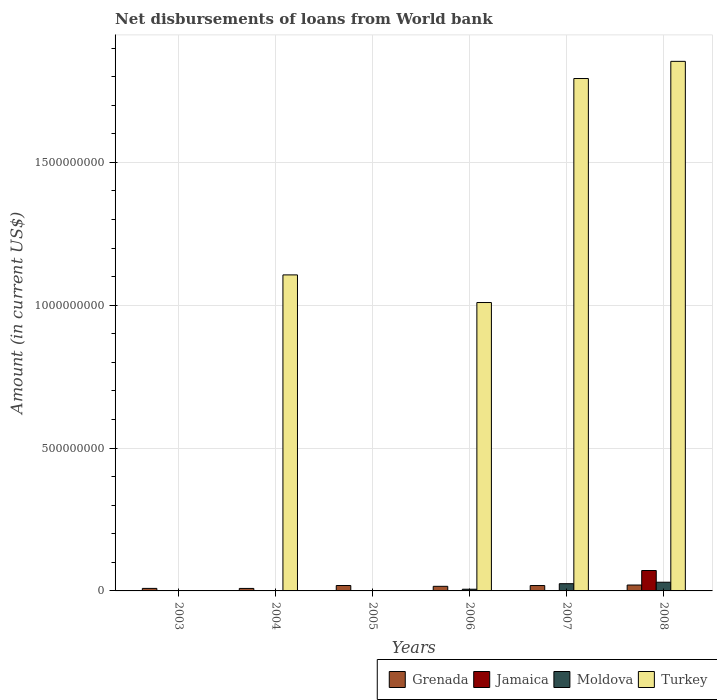How many different coloured bars are there?
Offer a very short reply. 4. Are the number of bars per tick equal to the number of legend labels?
Ensure brevity in your answer.  No. Are the number of bars on each tick of the X-axis equal?
Offer a terse response. No. How many bars are there on the 5th tick from the right?
Provide a succinct answer. 3. What is the label of the 3rd group of bars from the left?
Your response must be concise. 2005. In how many cases, is the number of bars for a given year not equal to the number of legend labels?
Offer a very short reply. 5. What is the amount of loan disbursed from World Bank in Grenada in 2008?
Offer a very short reply. 2.07e+07. Across all years, what is the maximum amount of loan disbursed from World Bank in Moldova?
Offer a very short reply. 3.04e+07. Across all years, what is the minimum amount of loan disbursed from World Bank in Grenada?
Offer a terse response. 8.74e+06. In which year was the amount of loan disbursed from World Bank in Turkey maximum?
Your answer should be compact. 2008. What is the total amount of loan disbursed from World Bank in Jamaica in the graph?
Your answer should be very brief. 7.19e+07. What is the difference between the amount of loan disbursed from World Bank in Turkey in 2004 and that in 2008?
Make the answer very short. -7.47e+08. What is the difference between the amount of loan disbursed from World Bank in Moldova in 2005 and the amount of loan disbursed from World Bank in Turkey in 2004?
Your answer should be compact. -1.11e+09. What is the average amount of loan disbursed from World Bank in Moldova per year?
Keep it short and to the point. 1.03e+07. In the year 2004, what is the difference between the amount of loan disbursed from World Bank in Turkey and amount of loan disbursed from World Bank in Jamaica?
Offer a terse response. 1.11e+09. In how many years, is the amount of loan disbursed from World Bank in Jamaica greater than 900000000 US$?
Give a very brief answer. 0. What is the ratio of the amount of loan disbursed from World Bank in Grenada in 2006 to that in 2008?
Keep it short and to the point. 0.78. What is the difference between the highest and the second highest amount of loan disbursed from World Bank in Moldova?
Your response must be concise. 5.12e+06. What is the difference between the highest and the lowest amount of loan disbursed from World Bank in Jamaica?
Provide a succinct answer. 7.14e+07. Is the sum of the amount of loan disbursed from World Bank in Turkey in 2004 and 2006 greater than the maximum amount of loan disbursed from World Bank in Grenada across all years?
Offer a very short reply. Yes. Is it the case that in every year, the sum of the amount of loan disbursed from World Bank in Turkey and amount of loan disbursed from World Bank in Grenada is greater than the sum of amount of loan disbursed from World Bank in Jamaica and amount of loan disbursed from World Bank in Moldova?
Your response must be concise. No. How many bars are there?
Provide a short and direct response. 15. Are all the bars in the graph horizontal?
Keep it short and to the point. No. What is the difference between two consecutive major ticks on the Y-axis?
Give a very brief answer. 5.00e+08. Does the graph contain grids?
Provide a succinct answer. Yes. How are the legend labels stacked?
Your answer should be very brief. Horizontal. What is the title of the graph?
Ensure brevity in your answer.  Net disbursements of loans from World bank. What is the label or title of the X-axis?
Give a very brief answer. Years. What is the label or title of the Y-axis?
Your answer should be very brief. Amount (in current US$). What is the Amount (in current US$) of Grenada in 2003?
Provide a short and direct response. 8.82e+06. What is the Amount (in current US$) of Moldova in 2003?
Offer a terse response. 0. What is the Amount (in current US$) in Turkey in 2003?
Ensure brevity in your answer.  0. What is the Amount (in current US$) in Grenada in 2004?
Your answer should be compact. 8.74e+06. What is the Amount (in current US$) of Jamaica in 2004?
Your response must be concise. 4.74e+05. What is the Amount (in current US$) of Moldova in 2004?
Give a very brief answer. 0. What is the Amount (in current US$) of Turkey in 2004?
Provide a short and direct response. 1.11e+09. What is the Amount (in current US$) of Grenada in 2005?
Provide a succinct answer. 1.90e+07. What is the Amount (in current US$) of Jamaica in 2005?
Provide a succinct answer. 0. What is the Amount (in current US$) of Moldova in 2005?
Your answer should be compact. 0. What is the Amount (in current US$) of Grenada in 2006?
Provide a short and direct response. 1.61e+07. What is the Amount (in current US$) of Jamaica in 2006?
Offer a terse response. 0. What is the Amount (in current US$) of Moldova in 2006?
Give a very brief answer. 5.95e+06. What is the Amount (in current US$) of Turkey in 2006?
Ensure brevity in your answer.  1.01e+09. What is the Amount (in current US$) of Grenada in 2007?
Offer a very short reply. 1.88e+07. What is the Amount (in current US$) of Moldova in 2007?
Provide a succinct answer. 2.53e+07. What is the Amount (in current US$) in Turkey in 2007?
Give a very brief answer. 1.79e+09. What is the Amount (in current US$) of Grenada in 2008?
Offer a terse response. 2.07e+07. What is the Amount (in current US$) in Jamaica in 2008?
Offer a very short reply. 7.14e+07. What is the Amount (in current US$) in Moldova in 2008?
Your answer should be very brief. 3.04e+07. What is the Amount (in current US$) of Turkey in 2008?
Ensure brevity in your answer.  1.85e+09. Across all years, what is the maximum Amount (in current US$) in Grenada?
Provide a succinct answer. 2.07e+07. Across all years, what is the maximum Amount (in current US$) of Jamaica?
Your answer should be very brief. 7.14e+07. Across all years, what is the maximum Amount (in current US$) of Moldova?
Offer a very short reply. 3.04e+07. Across all years, what is the maximum Amount (in current US$) of Turkey?
Your response must be concise. 1.85e+09. Across all years, what is the minimum Amount (in current US$) in Grenada?
Give a very brief answer. 8.74e+06. Across all years, what is the minimum Amount (in current US$) in Moldova?
Make the answer very short. 0. What is the total Amount (in current US$) of Grenada in the graph?
Ensure brevity in your answer.  9.21e+07. What is the total Amount (in current US$) of Jamaica in the graph?
Ensure brevity in your answer.  7.19e+07. What is the total Amount (in current US$) of Moldova in the graph?
Your answer should be compact. 6.17e+07. What is the total Amount (in current US$) in Turkey in the graph?
Offer a terse response. 5.76e+09. What is the difference between the Amount (in current US$) in Grenada in 2003 and that in 2004?
Ensure brevity in your answer.  7.60e+04. What is the difference between the Amount (in current US$) of Grenada in 2003 and that in 2005?
Keep it short and to the point. -1.02e+07. What is the difference between the Amount (in current US$) of Grenada in 2003 and that in 2006?
Offer a terse response. -7.28e+06. What is the difference between the Amount (in current US$) in Grenada in 2003 and that in 2007?
Provide a short and direct response. -1.00e+07. What is the difference between the Amount (in current US$) of Grenada in 2003 and that in 2008?
Offer a terse response. -1.18e+07. What is the difference between the Amount (in current US$) of Grenada in 2004 and that in 2005?
Ensure brevity in your answer.  -1.02e+07. What is the difference between the Amount (in current US$) of Grenada in 2004 and that in 2006?
Offer a very short reply. -7.36e+06. What is the difference between the Amount (in current US$) of Turkey in 2004 and that in 2006?
Ensure brevity in your answer.  9.67e+07. What is the difference between the Amount (in current US$) in Grenada in 2004 and that in 2007?
Ensure brevity in your answer.  -1.01e+07. What is the difference between the Amount (in current US$) in Turkey in 2004 and that in 2007?
Your answer should be compact. -6.87e+08. What is the difference between the Amount (in current US$) in Grenada in 2004 and that in 2008?
Provide a short and direct response. -1.19e+07. What is the difference between the Amount (in current US$) in Jamaica in 2004 and that in 2008?
Keep it short and to the point. -7.10e+07. What is the difference between the Amount (in current US$) in Turkey in 2004 and that in 2008?
Keep it short and to the point. -7.47e+08. What is the difference between the Amount (in current US$) of Grenada in 2005 and that in 2006?
Keep it short and to the point. 2.88e+06. What is the difference between the Amount (in current US$) of Grenada in 2005 and that in 2008?
Give a very brief answer. -1.68e+06. What is the difference between the Amount (in current US$) in Grenada in 2006 and that in 2007?
Your answer should be very brief. -2.72e+06. What is the difference between the Amount (in current US$) in Moldova in 2006 and that in 2007?
Your response must be concise. -1.94e+07. What is the difference between the Amount (in current US$) in Turkey in 2006 and that in 2007?
Make the answer very short. -7.84e+08. What is the difference between the Amount (in current US$) of Grenada in 2006 and that in 2008?
Your answer should be very brief. -4.55e+06. What is the difference between the Amount (in current US$) of Moldova in 2006 and that in 2008?
Offer a terse response. -2.45e+07. What is the difference between the Amount (in current US$) of Turkey in 2006 and that in 2008?
Make the answer very short. -8.44e+08. What is the difference between the Amount (in current US$) in Grenada in 2007 and that in 2008?
Your response must be concise. -1.84e+06. What is the difference between the Amount (in current US$) of Moldova in 2007 and that in 2008?
Your response must be concise. -5.12e+06. What is the difference between the Amount (in current US$) in Turkey in 2007 and that in 2008?
Provide a succinct answer. -6.01e+07. What is the difference between the Amount (in current US$) in Grenada in 2003 and the Amount (in current US$) in Jamaica in 2004?
Your answer should be very brief. 8.34e+06. What is the difference between the Amount (in current US$) of Grenada in 2003 and the Amount (in current US$) of Turkey in 2004?
Make the answer very short. -1.10e+09. What is the difference between the Amount (in current US$) of Grenada in 2003 and the Amount (in current US$) of Moldova in 2006?
Your answer should be very brief. 2.86e+06. What is the difference between the Amount (in current US$) of Grenada in 2003 and the Amount (in current US$) of Turkey in 2006?
Your answer should be very brief. -1.00e+09. What is the difference between the Amount (in current US$) of Grenada in 2003 and the Amount (in current US$) of Moldova in 2007?
Your answer should be compact. -1.65e+07. What is the difference between the Amount (in current US$) of Grenada in 2003 and the Amount (in current US$) of Turkey in 2007?
Your answer should be compact. -1.78e+09. What is the difference between the Amount (in current US$) of Grenada in 2003 and the Amount (in current US$) of Jamaica in 2008?
Offer a terse response. -6.26e+07. What is the difference between the Amount (in current US$) of Grenada in 2003 and the Amount (in current US$) of Moldova in 2008?
Give a very brief answer. -2.16e+07. What is the difference between the Amount (in current US$) of Grenada in 2003 and the Amount (in current US$) of Turkey in 2008?
Your response must be concise. -1.84e+09. What is the difference between the Amount (in current US$) of Grenada in 2004 and the Amount (in current US$) of Moldova in 2006?
Your response must be concise. 2.79e+06. What is the difference between the Amount (in current US$) of Grenada in 2004 and the Amount (in current US$) of Turkey in 2006?
Keep it short and to the point. -1.00e+09. What is the difference between the Amount (in current US$) in Jamaica in 2004 and the Amount (in current US$) in Moldova in 2006?
Keep it short and to the point. -5.48e+06. What is the difference between the Amount (in current US$) in Jamaica in 2004 and the Amount (in current US$) in Turkey in 2006?
Provide a short and direct response. -1.01e+09. What is the difference between the Amount (in current US$) of Grenada in 2004 and the Amount (in current US$) of Moldova in 2007?
Make the answer very short. -1.66e+07. What is the difference between the Amount (in current US$) of Grenada in 2004 and the Amount (in current US$) of Turkey in 2007?
Offer a terse response. -1.78e+09. What is the difference between the Amount (in current US$) in Jamaica in 2004 and the Amount (in current US$) in Moldova in 2007?
Keep it short and to the point. -2.48e+07. What is the difference between the Amount (in current US$) in Jamaica in 2004 and the Amount (in current US$) in Turkey in 2007?
Give a very brief answer. -1.79e+09. What is the difference between the Amount (in current US$) of Grenada in 2004 and the Amount (in current US$) of Jamaica in 2008?
Your response must be concise. -6.27e+07. What is the difference between the Amount (in current US$) in Grenada in 2004 and the Amount (in current US$) in Moldova in 2008?
Provide a succinct answer. -2.17e+07. What is the difference between the Amount (in current US$) of Grenada in 2004 and the Amount (in current US$) of Turkey in 2008?
Give a very brief answer. -1.84e+09. What is the difference between the Amount (in current US$) of Jamaica in 2004 and the Amount (in current US$) of Moldova in 2008?
Your answer should be very brief. -3.00e+07. What is the difference between the Amount (in current US$) in Jamaica in 2004 and the Amount (in current US$) in Turkey in 2008?
Make the answer very short. -1.85e+09. What is the difference between the Amount (in current US$) of Grenada in 2005 and the Amount (in current US$) of Moldova in 2006?
Ensure brevity in your answer.  1.30e+07. What is the difference between the Amount (in current US$) of Grenada in 2005 and the Amount (in current US$) of Turkey in 2006?
Offer a terse response. -9.90e+08. What is the difference between the Amount (in current US$) of Grenada in 2005 and the Amount (in current US$) of Moldova in 2007?
Provide a short and direct response. -6.34e+06. What is the difference between the Amount (in current US$) of Grenada in 2005 and the Amount (in current US$) of Turkey in 2007?
Provide a short and direct response. -1.77e+09. What is the difference between the Amount (in current US$) of Grenada in 2005 and the Amount (in current US$) of Jamaica in 2008?
Give a very brief answer. -5.25e+07. What is the difference between the Amount (in current US$) of Grenada in 2005 and the Amount (in current US$) of Moldova in 2008?
Give a very brief answer. -1.15e+07. What is the difference between the Amount (in current US$) of Grenada in 2005 and the Amount (in current US$) of Turkey in 2008?
Provide a succinct answer. -1.83e+09. What is the difference between the Amount (in current US$) of Grenada in 2006 and the Amount (in current US$) of Moldova in 2007?
Your answer should be very brief. -9.21e+06. What is the difference between the Amount (in current US$) in Grenada in 2006 and the Amount (in current US$) in Turkey in 2007?
Provide a short and direct response. -1.78e+09. What is the difference between the Amount (in current US$) in Moldova in 2006 and the Amount (in current US$) in Turkey in 2007?
Your response must be concise. -1.79e+09. What is the difference between the Amount (in current US$) of Grenada in 2006 and the Amount (in current US$) of Jamaica in 2008?
Ensure brevity in your answer.  -5.53e+07. What is the difference between the Amount (in current US$) of Grenada in 2006 and the Amount (in current US$) of Moldova in 2008?
Your answer should be very brief. -1.43e+07. What is the difference between the Amount (in current US$) in Grenada in 2006 and the Amount (in current US$) in Turkey in 2008?
Provide a succinct answer. -1.84e+09. What is the difference between the Amount (in current US$) of Moldova in 2006 and the Amount (in current US$) of Turkey in 2008?
Offer a very short reply. -1.85e+09. What is the difference between the Amount (in current US$) of Grenada in 2007 and the Amount (in current US$) of Jamaica in 2008?
Provide a succinct answer. -5.26e+07. What is the difference between the Amount (in current US$) of Grenada in 2007 and the Amount (in current US$) of Moldova in 2008?
Provide a short and direct response. -1.16e+07. What is the difference between the Amount (in current US$) of Grenada in 2007 and the Amount (in current US$) of Turkey in 2008?
Give a very brief answer. -1.83e+09. What is the difference between the Amount (in current US$) in Moldova in 2007 and the Amount (in current US$) in Turkey in 2008?
Make the answer very short. -1.83e+09. What is the average Amount (in current US$) in Grenada per year?
Your response must be concise. 1.53e+07. What is the average Amount (in current US$) in Jamaica per year?
Your answer should be compact. 1.20e+07. What is the average Amount (in current US$) in Moldova per year?
Provide a short and direct response. 1.03e+07. What is the average Amount (in current US$) in Turkey per year?
Make the answer very short. 9.60e+08. In the year 2004, what is the difference between the Amount (in current US$) in Grenada and Amount (in current US$) in Jamaica?
Offer a terse response. 8.27e+06. In the year 2004, what is the difference between the Amount (in current US$) of Grenada and Amount (in current US$) of Turkey?
Provide a short and direct response. -1.10e+09. In the year 2004, what is the difference between the Amount (in current US$) of Jamaica and Amount (in current US$) of Turkey?
Keep it short and to the point. -1.11e+09. In the year 2006, what is the difference between the Amount (in current US$) in Grenada and Amount (in current US$) in Moldova?
Provide a succinct answer. 1.01e+07. In the year 2006, what is the difference between the Amount (in current US$) in Grenada and Amount (in current US$) in Turkey?
Your response must be concise. -9.93e+08. In the year 2006, what is the difference between the Amount (in current US$) of Moldova and Amount (in current US$) of Turkey?
Provide a short and direct response. -1.00e+09. In the year 2007, what is the difference between the Amount (in current US$) in Grenada and Amount (in current US$) in Moldova?
Your answer should be compact. -6.50e+06. In the year 2007, what is the difference between the Amount (in current US$) of Grenada and Amount (in current US$) of Turkey?
Make the answer very short. -1.77e+09. In the year 2007, what is the difference between the Amount (in current US$) in Moldova and Amount (in current US$) in Turkey?
Ensure brevity in your answer.  -1.77e+09. In the year 2008, what is the difference between the Amount (in current US$) of Grenada and Amount (in current US$) of Jamaica?
Your response must be concise. -5.08e+07. In the year 2008, what is the difference between the Amount (in current US$) of Grenada and Amount (in current US$) of Moldova?
Provide a succinct answer. -9.78e+06. In the year 2008, what is the difference between the Amount (in current US$) of Grenada and Amount (in current US$) of Turkey?
Your answer should be compact. -1.83e+09. In the year 2008, what is the difference between the Amount (in current US$) in Jamaica and Amount (in current US$) in Moldova?
Offer a terse response. 4.10e+07. In the year 2008, what is the difference between the Amount (in current US$) in Jamaica and Amount (in current US$) in Turkey?
Your answer should be compact. -1.78e+09. In the year 2008, what is the difference between the Amount (in current US$) of Moldova and Amount (in current US$) of Turkey?
Ensure brevity in your answer.  -1.82e+09. What is the ratio of the Amount (in current US$) in Grenada in 2003 to that in 2004?
Make the answer very short. 1.01. What is the ratio of the Amount (in current US$) of Grenada in 2003 to that in 2005?
Offer a terse response. 0.46. What is the ratio of the Amount (in current US$) of Grenada in 2003 to that in 2006?
Keep it short and to the point. 0.55. What is the ratio of the Amount (in current US$) in Grenada in 2003 to that in 2007?
Make the answer very short. 0.47. What is the ratio of the Amount (in current US$) in Grenada in 2003 to that in 2008?
Give a very brief answer. 0.43. What is the ratio of the Amount (in current US$) in Grenada in 2004 to that in 2005?
Keep it short and to the point. 0.46. What is the ratio of the Amount (in current US$) in Grenada in 2004 to that in 2006?
Your answer should be compact. 0.54. What is the ratio of the Amount (in current US$) of Turkey in 2004 to that in 2006?
Give a very brief answer. 1.1. What is the ratio of the Amount (in current US$) of Grenada in 2004 to that in 2007?
Your response must be concise. 0.46. What is the ratio of the Amount (in current US$) of Turkey in 2004 to that in 2007?
Your answer should be compact. 0.62. What is the ratio of the Amount (in current US$) of Grenada in 2004 to that in 2008?
Make the answer very short. 0.42. What is the ratio of the Amount (in current US$) of Jamaica in 2004 to that in 2008?
Your answer should be compact. 0.01. What is the ratio of the Amount (in current US$) in Turkey in 2004 to that in 2008?
Provide a succinct answer. 0.6. What is the ratio of the Amount (in current US$) of Grenada in 2005 to that in 2006?
Provide a succinct answer. 1.18. What is the ratio of the Amount (in current US$) of Grenada in 2005 to that in 2007?
Your response must be concise. 1.01. What is the ratio of the Amount (in current US$) of Grenada in 2005 to that in 2008?
Make the answer very short. 0.92. What is the ratio of the Amount (in current US$) of Grenada in 2006 to that in 2007?
Provide a succinct answer. 0.86. What is the ratio of the Amount (in current US$) of Moldova in 2006 to that in 2007?
Offer a very short reply. 0.24. What is the ratio of the Amount (in current US$) in Turkey in 2006 to that in 2007?
Ensure brevity in your answer.  0.56. What is the ratio of the Amount (in current US$) of Grenada in 2006 to that in 2008?
Your answer should be very brief. 0.78. What is the ratio of the Amount (in current US$) in Moldova in 2006 to that in 2008?
Provide a succinct answer. 0.2. What is the ratio of the Amount (in current US$) of Turkey in 2006 to that in 2008?
Ensure brevity in your answer.  0.54. What is the ratio of the Amount (in current US$) in Grenada in 2007 to that in 2008?
Offer a terse response. 0.91. What is the ratio of the Amount (in current US$) in Moldova in 2007 to that in 2008?
Your answer should be very brief. 0.83. What is the ratio of the Amount (in current US$) in Turkey in 2007 to that in 2008?
Your response must be concise. 0.97. What is the difference between the highest and the second highest Amount (in current US$) in Grenada?
Ensure brevity in your answer.  1.68e+06. What is the difference between the highest and the second highest Amount (in current US$) in Moldova?
Your answer should be very brief. 5.12e+06. What is the difference between the highest and the second highest Amount (in current US$) in Turkey?
Keep it short and to the point. 6.01e+07. What is the difference between the highest and the lowest Amount (in current US$) in Grenada?
Offer a terse response. 1.19e+07. What is the difference between the highest and the lowest Amount (in current US$) in Jamaica?
Ensure brevity in your answer.  7.14e+07. What is the difference between the highest and the lowest Amount (in current US$) in Moldova?
Offer a very short reply. 3.04e+07. What is the difference between the highest and the lowest Amount (in current US$) of Turkey?
Provide a short and direct response. 1.85e+09. 